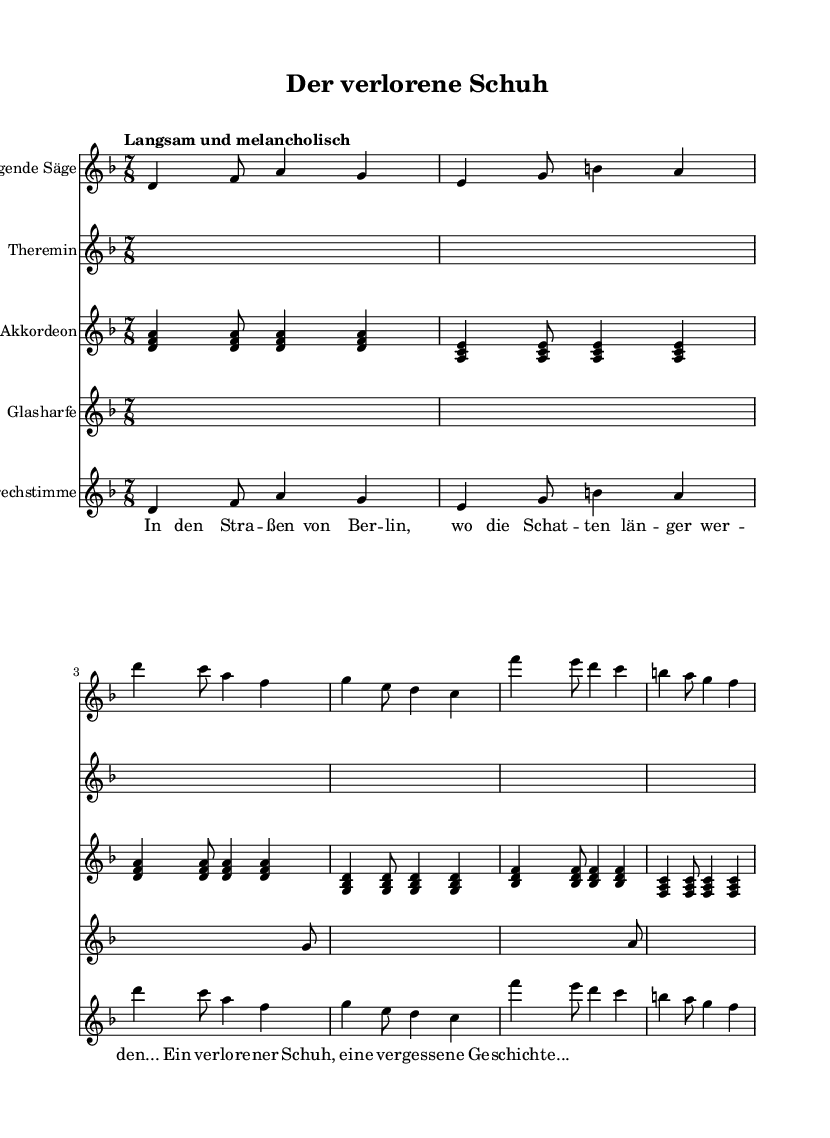What is the key signature of this music? The key signature is D minor, indicated by the presence of one flat (B flat) in the music.
Answer: D minor What is the time signature of this piece? The time signature is 7/8, which is shown at the beginning of the score, indicating a compound meter that has seven eighth notes per measure.
Answer: 7/8 What tempo marking is given for this composition? The tempo marking is "Langsam und melancholisch," which suggests that the music should be played slowly and with a melancholic feel.
Answer: Langsam und melancholisch How many instruments are featured in the score? There are five instruments listed in the score: Singende Säge, Theremin, Akkordeon, Glasharfe, and Sprechstimme. This can be counted from the indicated staves in the score.
Answer: Five What is the first note of the Singende Säge part? The first note of the Singende Säge part is D, which is clear from the notation at the beginning of that staff.
Answer: D How does the Akkordeon part differ in the verse compared to the chorus? The Akkordeon part features different chord patterns in the verse, focusing on D minor and G minor, while in the chorus, it shifts to B flat major and F major, highlighting the contrasting harmonic structures in both sections.
Answer: Different chord patterns What is the mood conveyed by the instrument combinations in this score? The combination of unconventional instruments like the Theremin and Singende Säge creates an atmospheric and haunting effect, enhancing the storytelling aspect of deconstructed folk music.
Answer: Atmospheric and haunting 